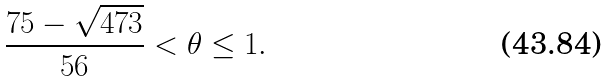<formula> <loc_0><loc_0><loc_500><loc_500>\frac { 7 5 - \sqrt { 4 7 3 } } { 5 6 } < \theta \leq 1 .</formula> 